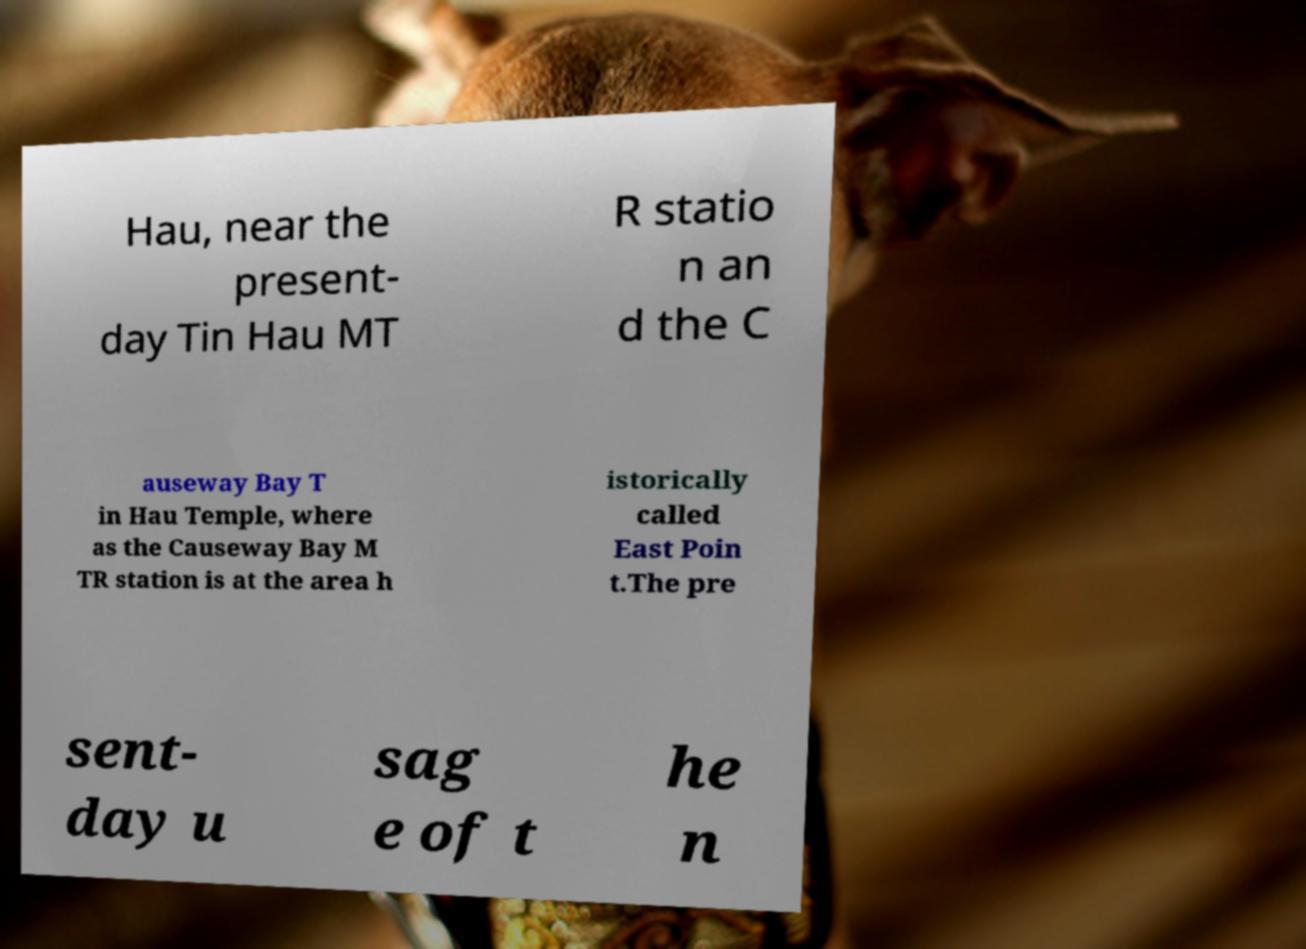Could you extract and type out the text from this image? Hau, near the present- day Tin Hau MT R statio n an d the C auseway Bay T in Hau Temple, where as the Causeway Bay M TR station is at the area h istorically called East Poin t.The pre sent- day u sag e of t he n 